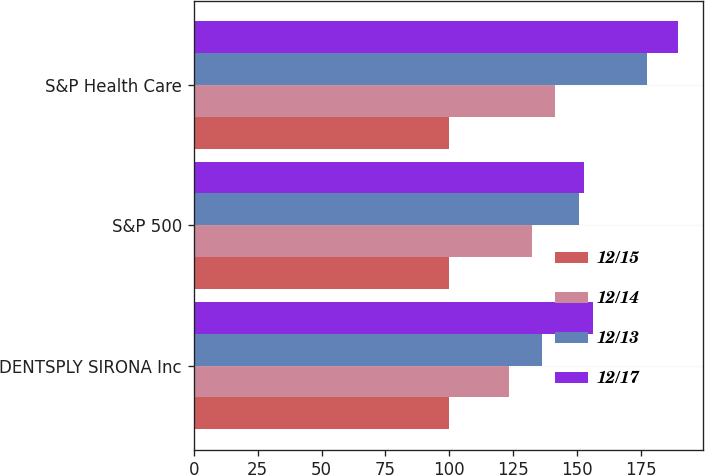<chart> <loc_0><loc_0><loc_500><loc_500><stacked_bar_chart><ecel><fcel>DENTSPLY SIRONA Inc<fcel>S&P 500<fcel>S&P Health Care<nl><fcel>12/15<fcel>100<fcel>100<fcel>100<nl><fcel>12/14<fcel>123.1<fcel>132.39<fcel>141.46<nl><fcel>12/13<fcel>136.01<fcel>150.51<fcel>177.3<nl><fcel>12/17<fcel>156.2<fcel>152.59<fcel>189.52<nl></chart> 